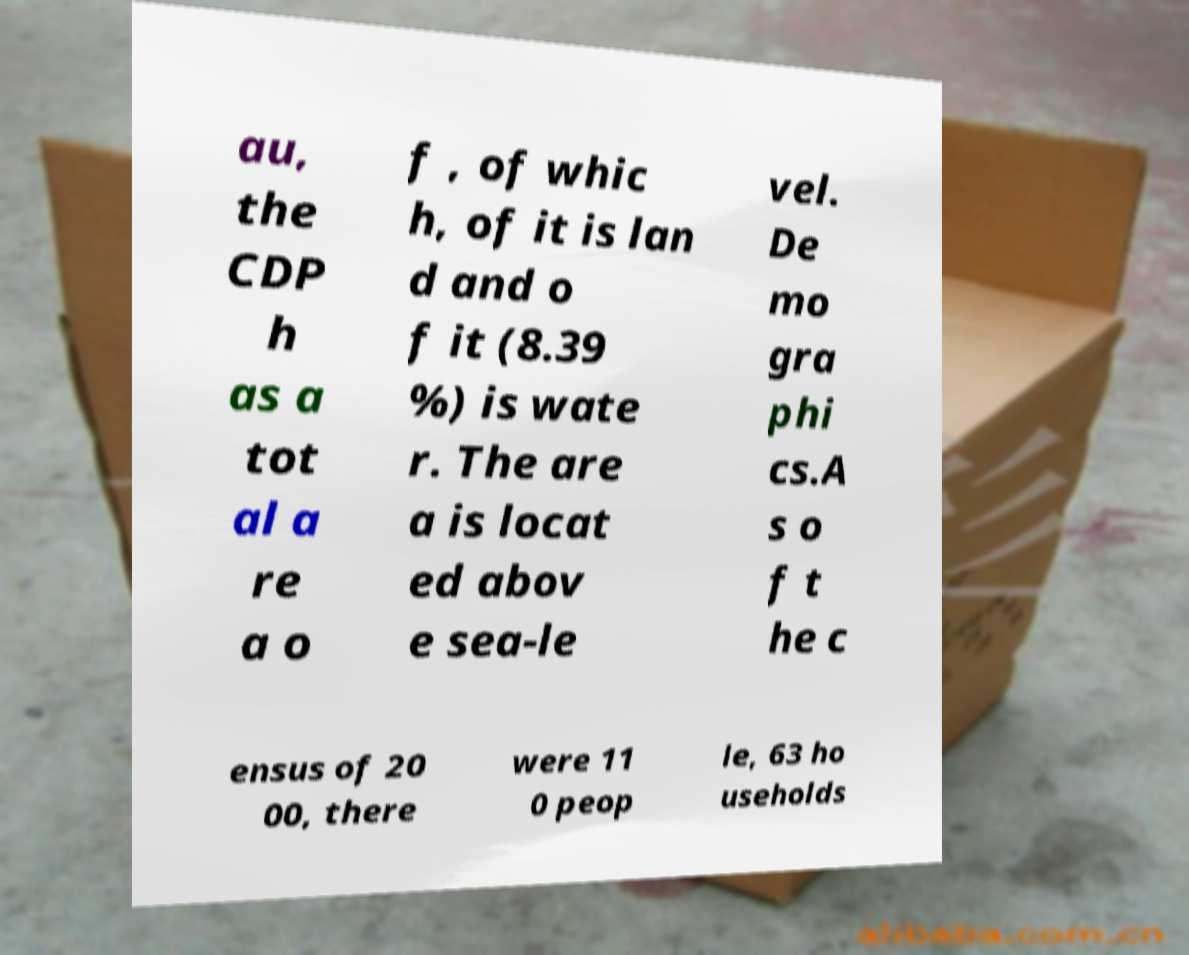Could you assist in decoding the text presented in this image and type it out clearly? au, the CDP h as a tot al a re a o f , of whic h, of it is lan d and o f it (8.39 %) is wate r. The are a is locat ed abov e sea-le vel. De mo gra phi cs.A s o f t he c ensus of 20 00, there were 11 0 peop le, 63 ho useholds 